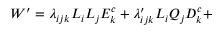Convert formula to latex. <formula><loc_0><loc_0><loc_500><loc_500>W ^ { \prime } = \lambda _ { i j k } L _ { i } L _ { j } E _ { k } ^ { c } + \lambda _ { i j k } ^ { \prime } L _ { i } Q _ { j } D _ { k } ^ { c } +</formula> 